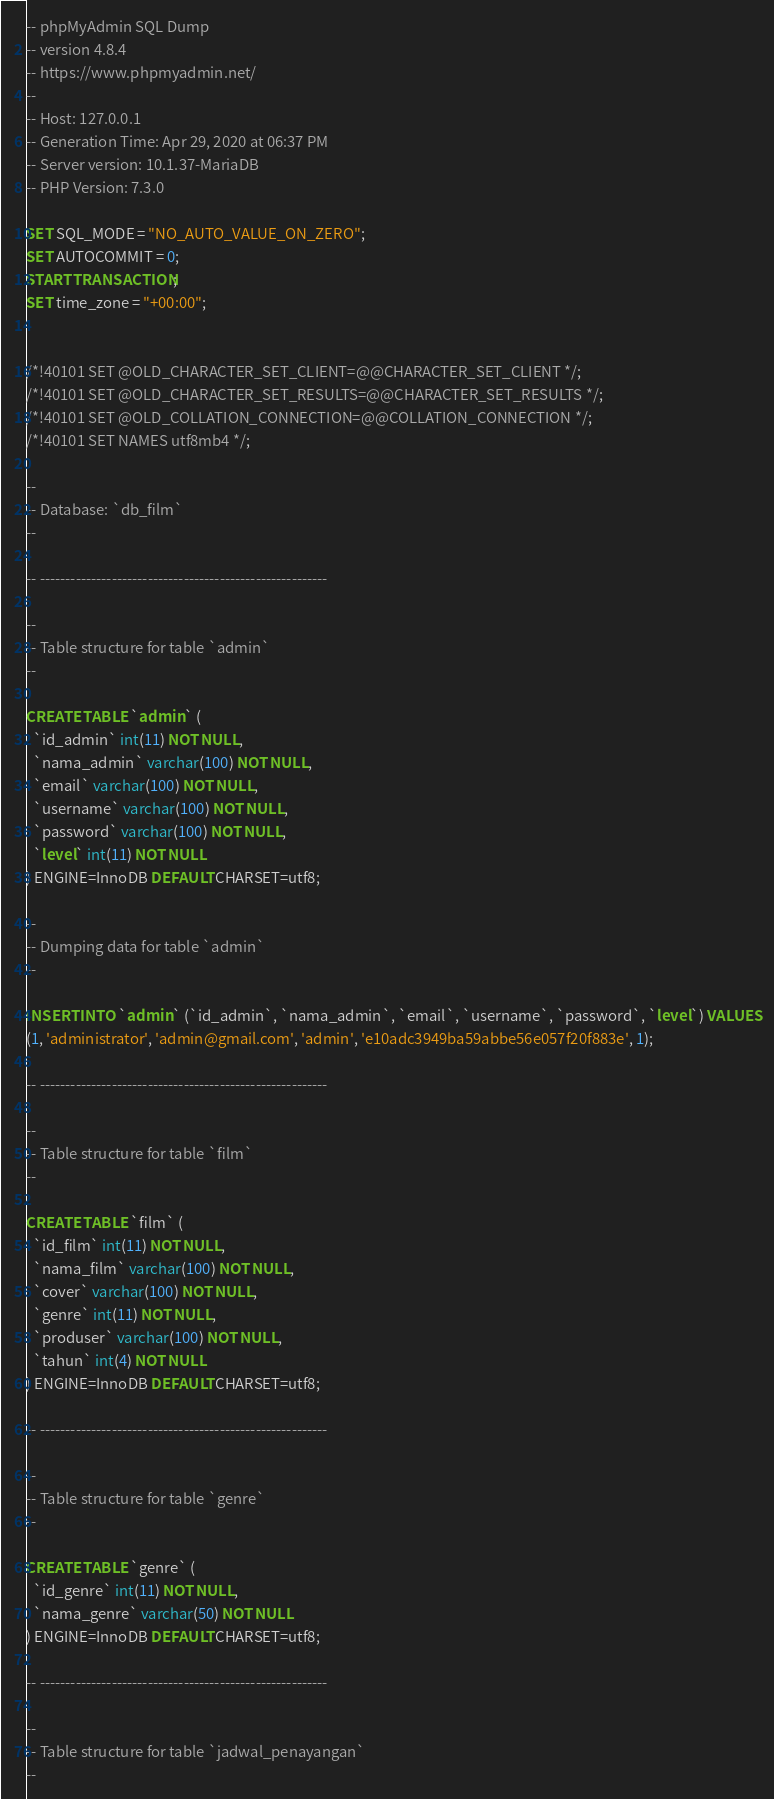<code> <loc_0><loc_0><loc_500><loc_500><_SQL_>-- phpMyAdmin SQL Dump
-- version 4.8.4
-- https://www.phpmyadmin.net/
--
-- Host: 127.0.0.1
-- Generation Time: Apr 29, 2020 at 06:37 PM
-- Server version: 10.1.37-MariaDB
-- PHP Version: 7.3.0

SET SQL_MODE = "NO_AUTO_VALUE_ON_ZERO";
SET AUTOCOMMIT = 0;
START TRANSACTION;
SET time_zone = "+00:00";


/*!40101 SET @OLD_CHARACTER_SET_CLIENT=@@CHARACTER_SET_CLIENT */;
/*!40101 SET @OLD_CHARACTER_SET_RESULTS=@@CHARACTER_SET_RESULTS */;
/*!40101 SET @OLD_COLLATION_CONNECTION=@@COLLATION_CONNECTION */;
/*!40101 SET NAMES utf8mb4 */;

--
-- Database: `db_film`
--

-- --------------------------------------------------------

--
-- Table structure for table `admin`
--

CREATE TABLE `admin` (
  `id_admin` int(11) NOT NULL,
  `nama_admin` varchar(100) NOT NULL,
  `email` varchar(100) NOT NULL,
  `username` varchar(100) NOT NULL,
  `password` varchar(100) NOT NULL,
  `level` int(11) NOT NULL
) ENGINE=InnoDB DEFAULT CHARSET=utf8;

--
-- Dumping data for table `admin`
--

INSERT INTO `admin` (`id_admin`, `nama_admin`, `email`, `username`, `password`, `level`) VALUES
(1, 'administrator', 'admin@gmail.com', 'admin', 'e10adc3949ba59abbe56e057f20f883e', 1);

-- --------------------------------------------------------

--
-- Table structure for table `film`
--

CREATE TABLE `film` (
  `id_film` int(11) NOT NULL,
  `nama_film` varchar(100) NOT NULL,
  `cover` varchar(100) NOT NULL,
  `genre` int(11) NOT NULL,
  `produser` varchar(100) NOT NULL,
  `tahun` int(4) NOT NULL
) ENGINE=InnoDB DEFAULT CHARSET=utf8;

-- --------------------------------------------------------

--
-- Table structure for table `genre`
--

CREATE TABLE `genre` (
  `id_genre` int(11) NOT NULL,
  `nama_genre` varchar(50) NOT NULL
) ENGINE=InnoDB DEFAULT CHARSET=utf8;

-- --------------------------------------------------------

--
-- Table structure for table `jadwal_penayangan`
--
</code> 